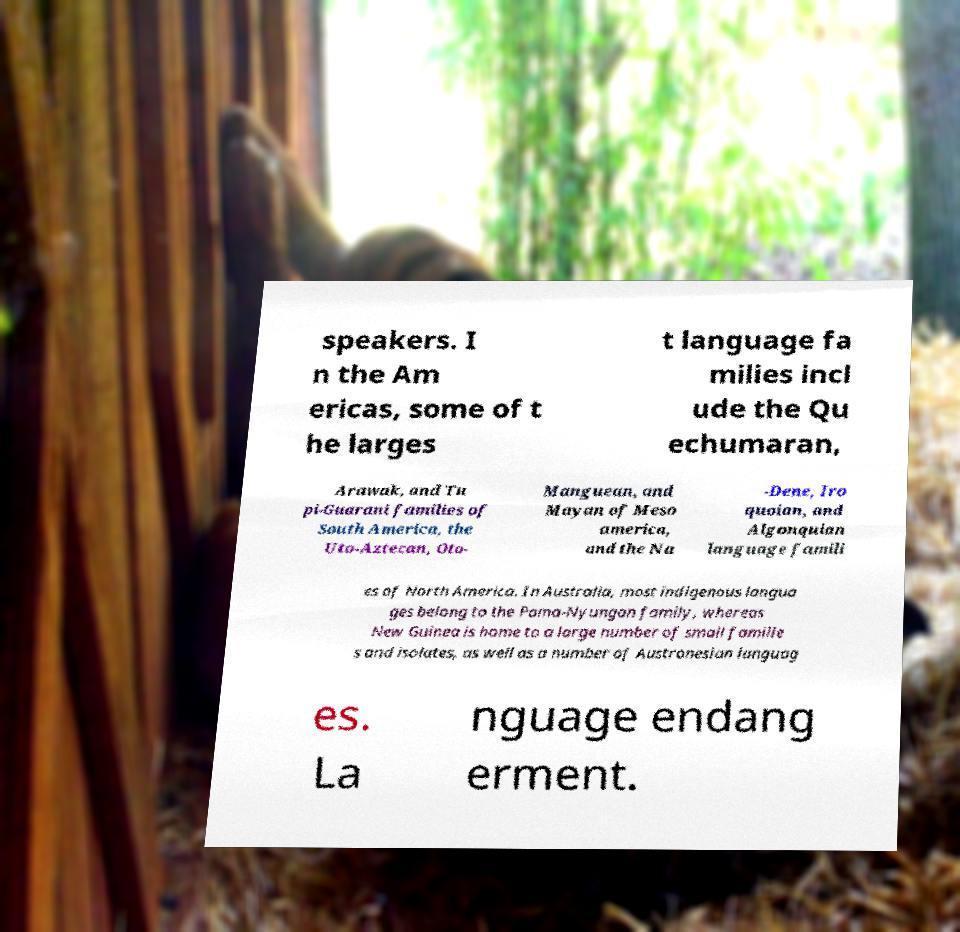Could you extract and type out the text from this image? speakers. I n the Am ericas, some of t he larges t language fa milies incl ude the Qu echumaran, Arawak, and Tu pi-Guarani families of South America, the Uto-Aztecan, Oto- Manguean, and Mayan of Meso america, and the Na -Dene, Iro quoian, and Algonquian language famili es of North America. In Australia, most indigenous langua ges belong to the Pama-Nyungan family, whereas New Guinea is home to a large number of small familie s and isolates, as well as a number of Austronesian languag es. La nguage endang erment. 